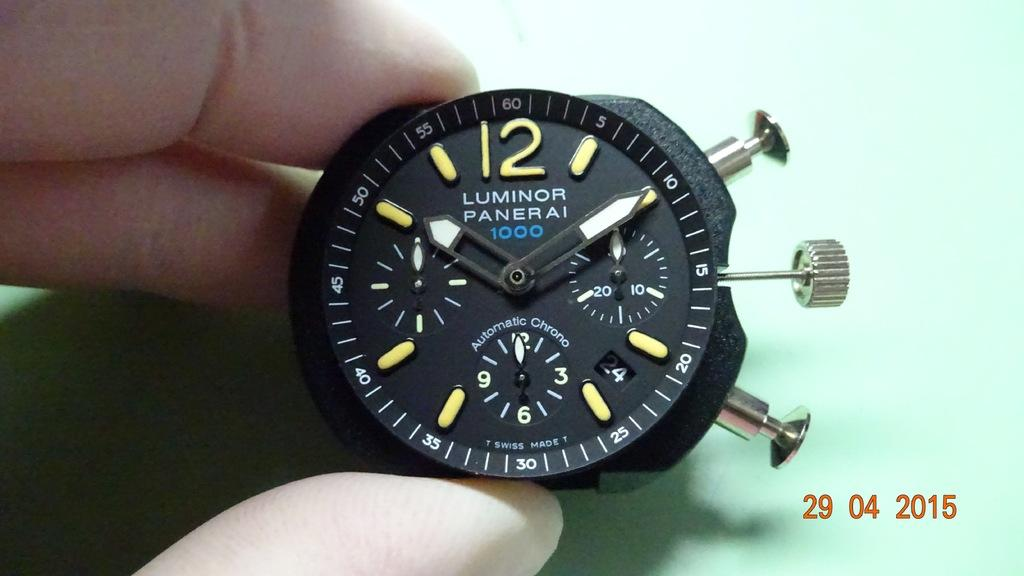<image>
Present a compact description of the photo's key features. A Luminor Panerai watch currently showing 10:10 as the time. 